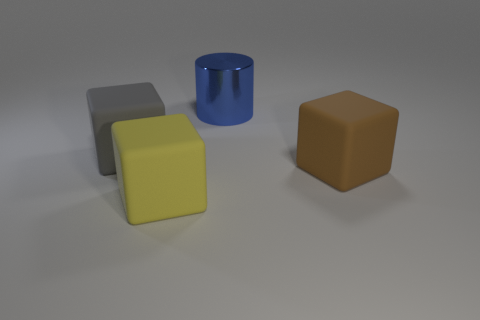What is the shape of the large thing behind the block on the left side of the yellow thing? cylinder 